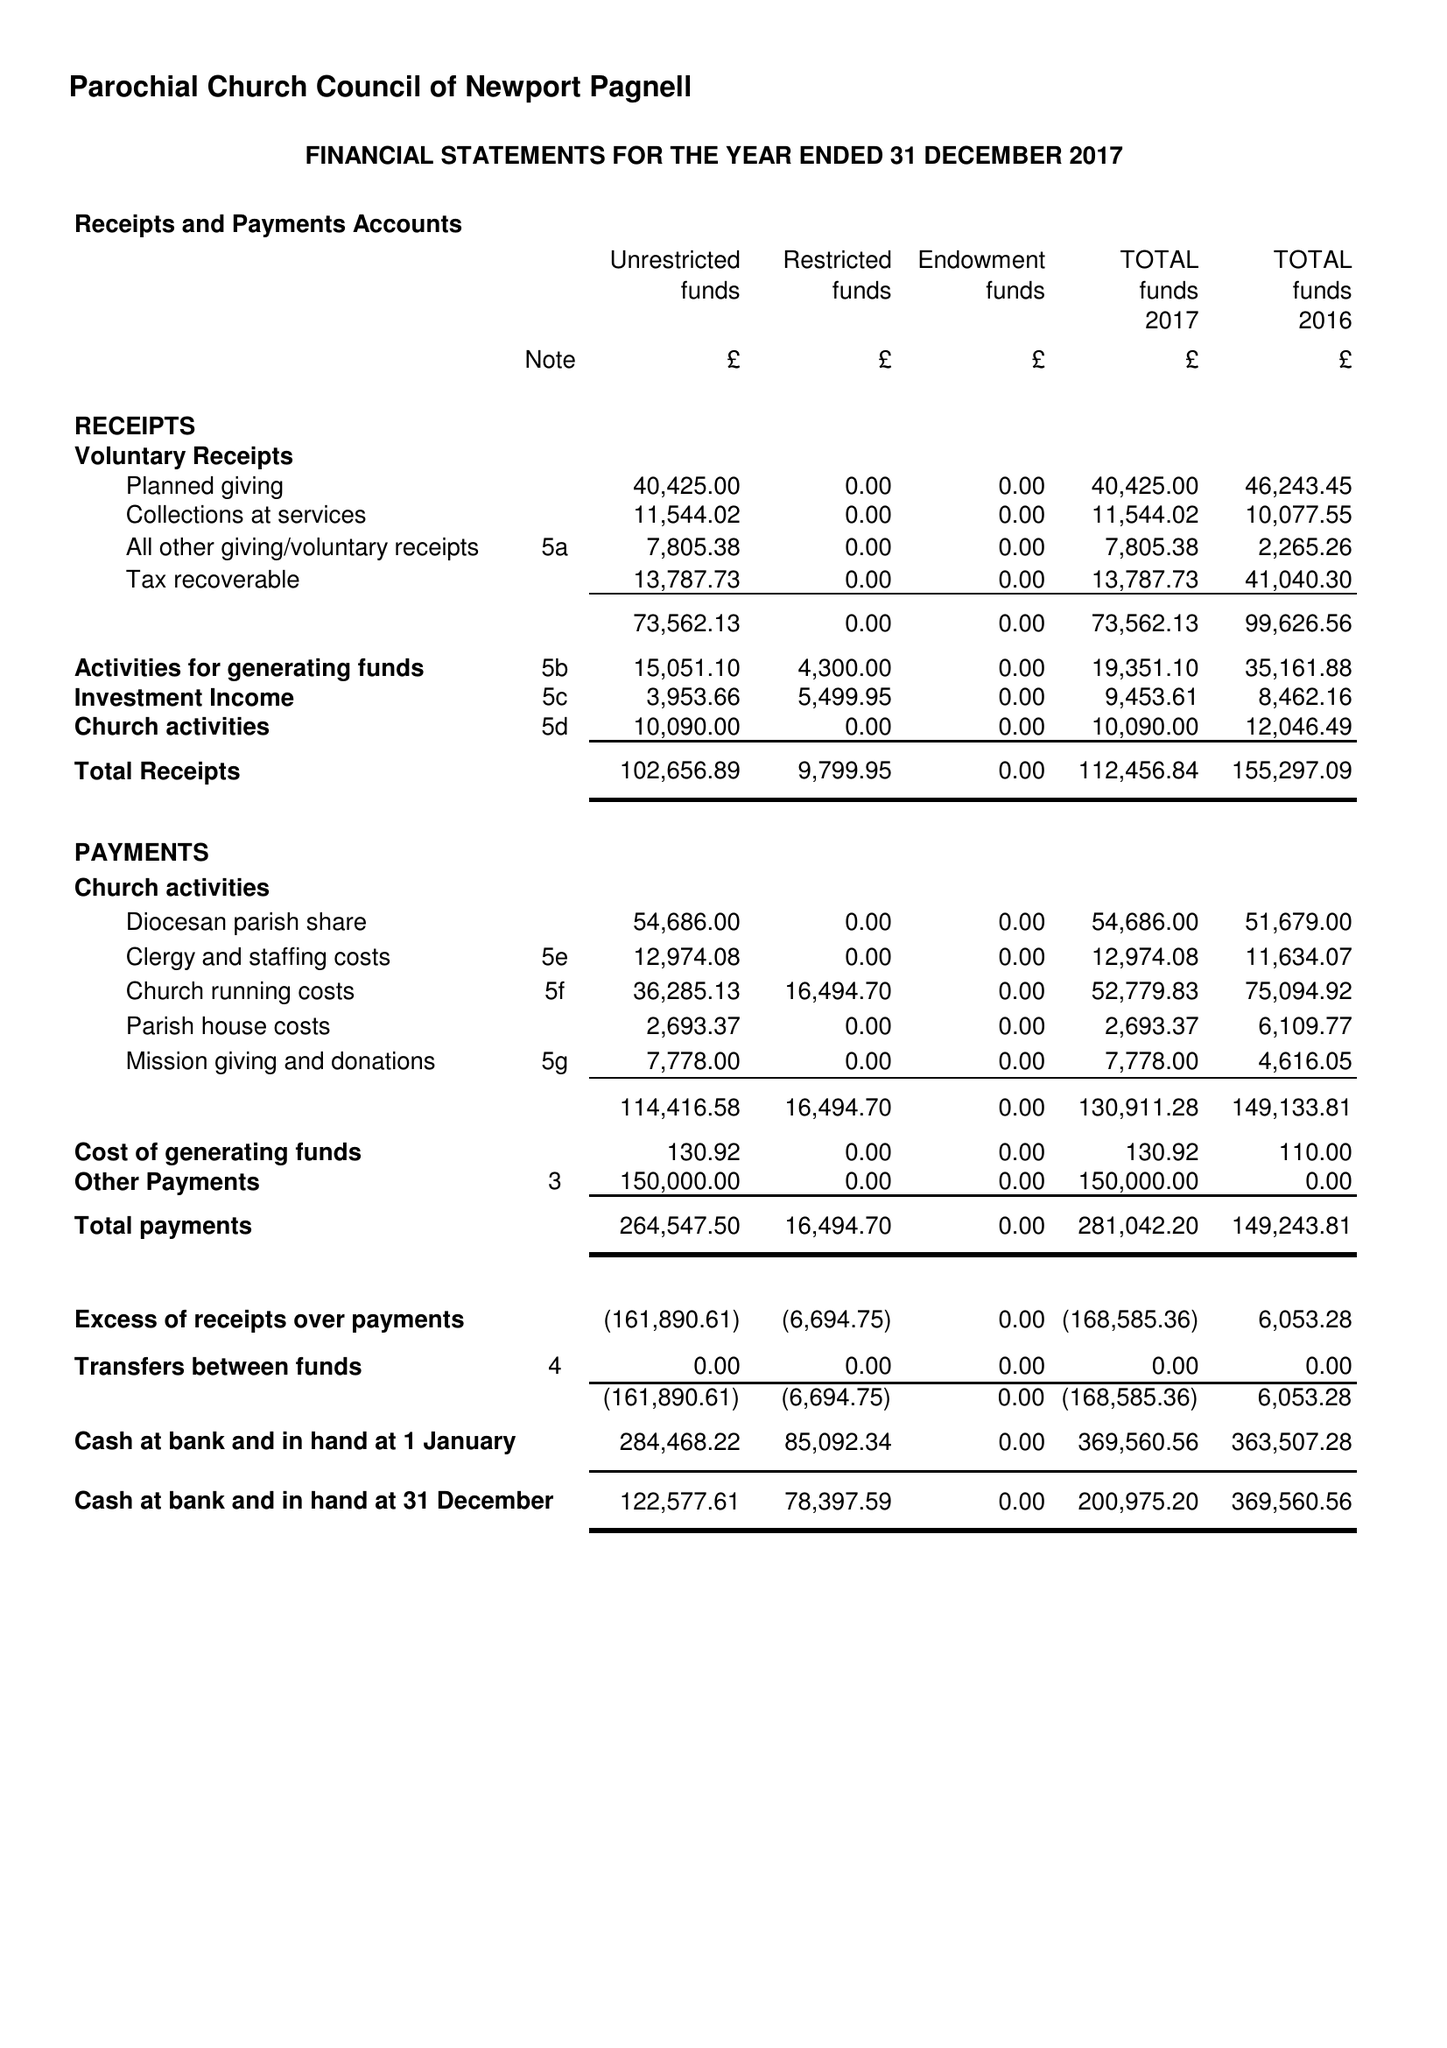What is the value for the address__post_town?
Answer the question using a single word or phrase. NEWPORT PAGNELL 